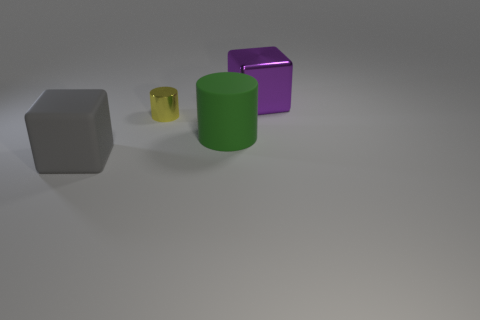Are there any metal cubes in front of the block that is right of the large gray matte object?
Ensure brevity in your answer.  No. The other large thing that is the same shape as the purple thing is what color?
Make the answer very short. Gray. What number of other shiny cylinders have the same color as the tiny metal cylinder?
Your response must be concise. 0. There is a matte thing that is behind the big rubber object on the left side of the big green matte thing in front of the purple block; what is its color?
Provide a succinct answer. Green. Is the green object made of the same material as the gray object?
Your answer should be very brief. Yes. Does the green object have the same shape as the purple object?
Give a very brief answer. No. Are there the same number of gray blocks that are behind the yellow cylinder and tiny yellow shiny cylinders that are to the right of the purple block?
Your answer should be very brief. Yes. There is a thing that is the same material as the gray cube; what is its color?
Your answer should be compact. Green. What number of gray blocks are made of the same material as the large green thing?
Provide a succinct answer. 1. Is the color of the large matte object that is on the left side of the tiny yellow cylinder the same as the small thing?
Provide a succinct answer. No. 